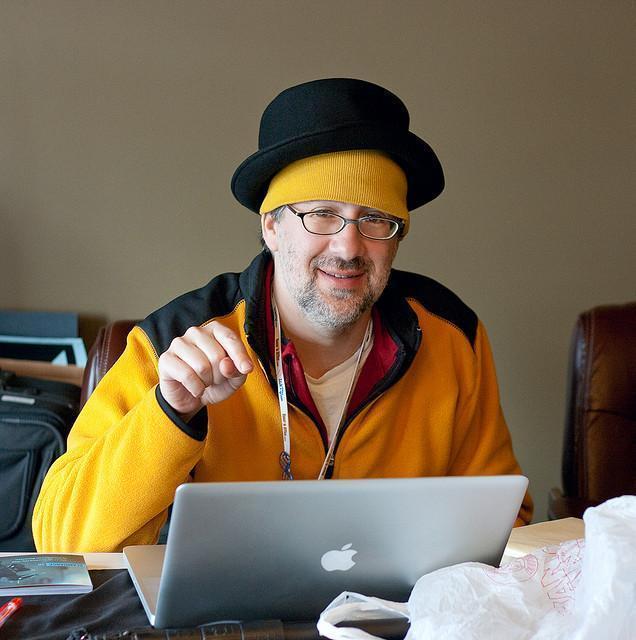What is the man's hat called?
Indicate the correct response by choosing from the four available options to answer the question.
Options: Felt, bowler hat, coach, trilby. Bowler hat. 